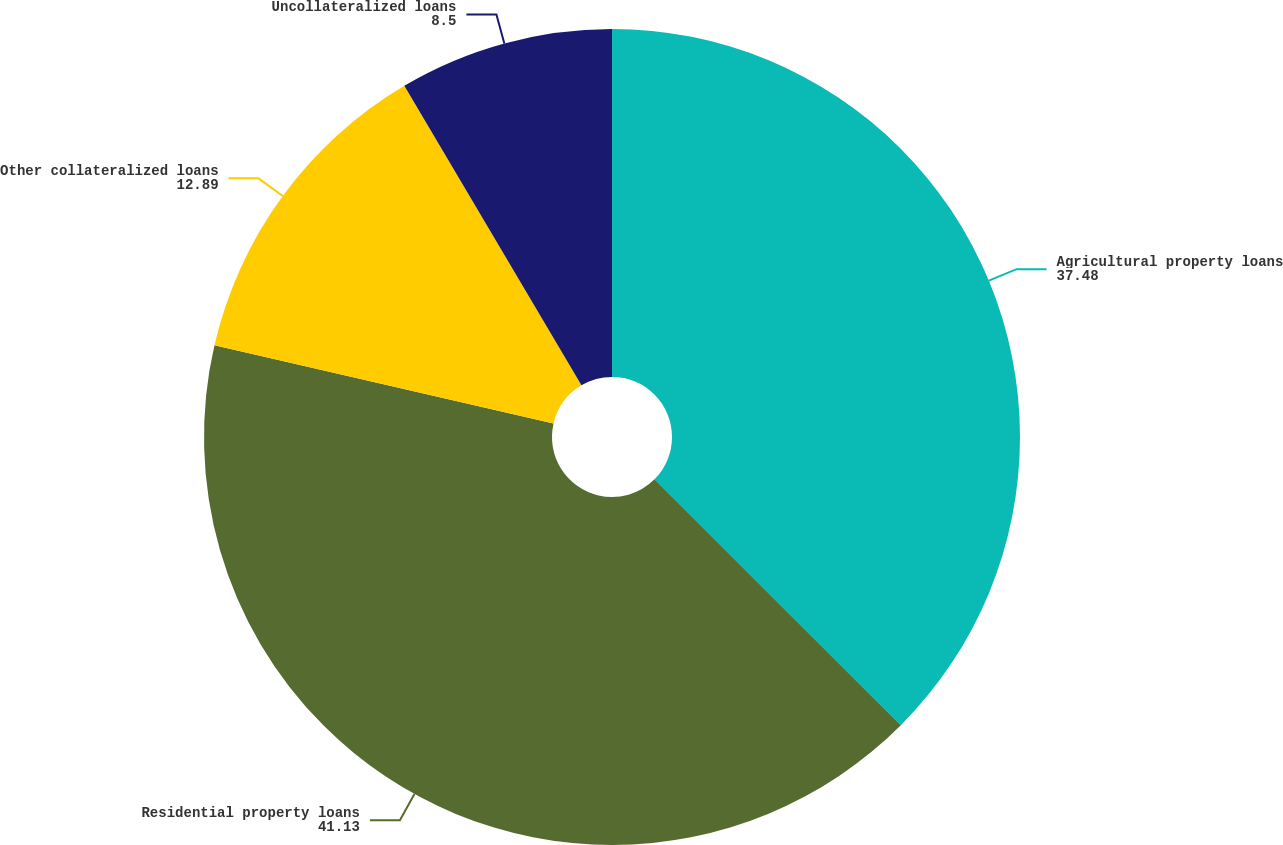Convert chart. <chart><loc_0><loc_0><loc_500><loc_500><pie_chart><fcel>Agricultural property loans<fcel>Residential property loans<fcel>Other collateralized loans<fcel>Uncollateralized loans<nl><fcel>37.48%<fcel>41.13%<fcel>12.89%<fcel>8.5%<nl></chart> 